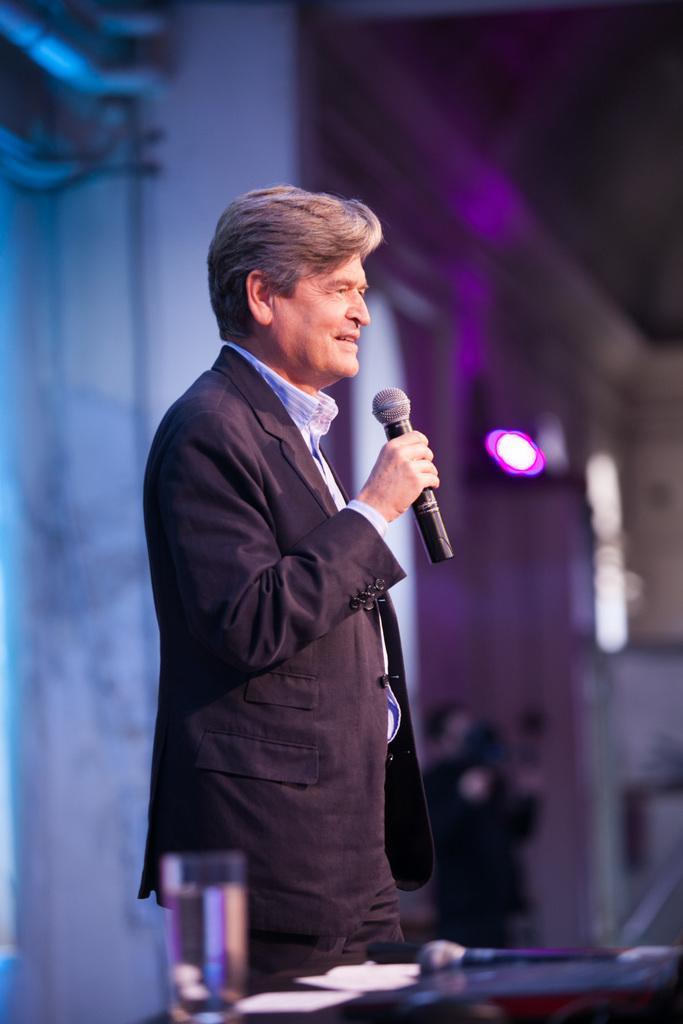Could you give a brief overview of what you see in this image? In this image I see a man who is standing and he is also wearing a suit, I can see that he is holding a mic in his hand and I see a glass, a mic and few papers over here. In the background I see the violet colored light. 